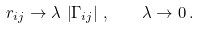<formula> <loc_0><loc_0><loc_500><loc_500>r _ { i j } \to \lambda \, \left | \Gamma _ { i j } \right | \, , \quad \lambda \to 0 \, .</formula> 